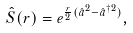Convert formula to latex. <formula><loc_0><loc_0><loc_500><loc_500>\hat { S } ( r ) = e ^ { \frac { r } { 2 } ( \hat { a } ^ { 2 } - \hat { a } ^ { \dagger 2 } ) } ,</formula> 